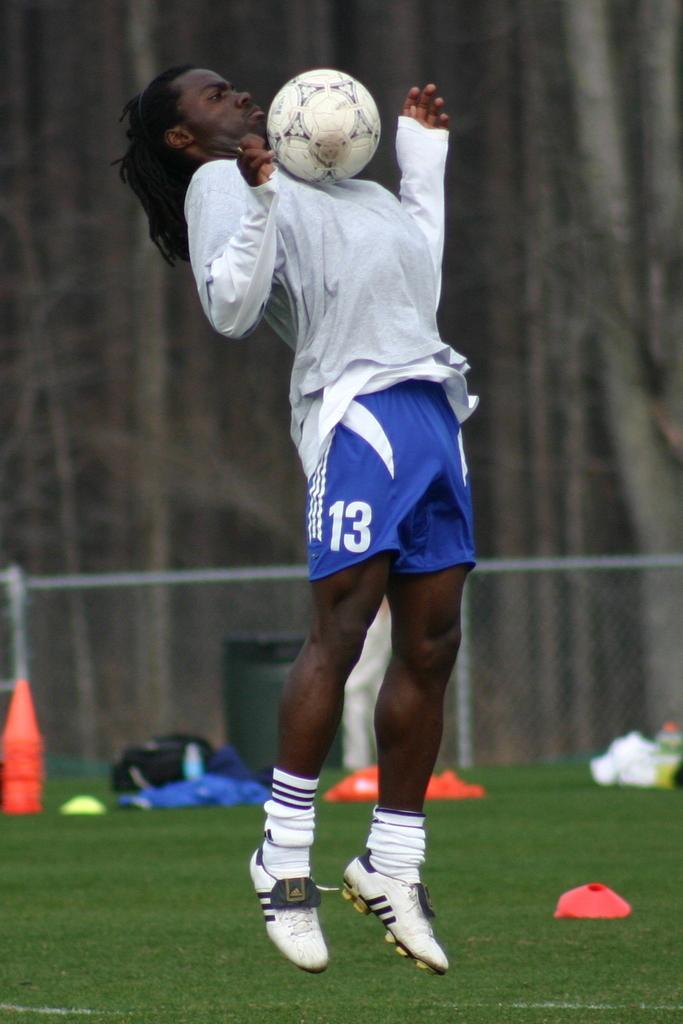In one or two sentences, can you explain what this image depicts? In this image I can see a man and a ball. 